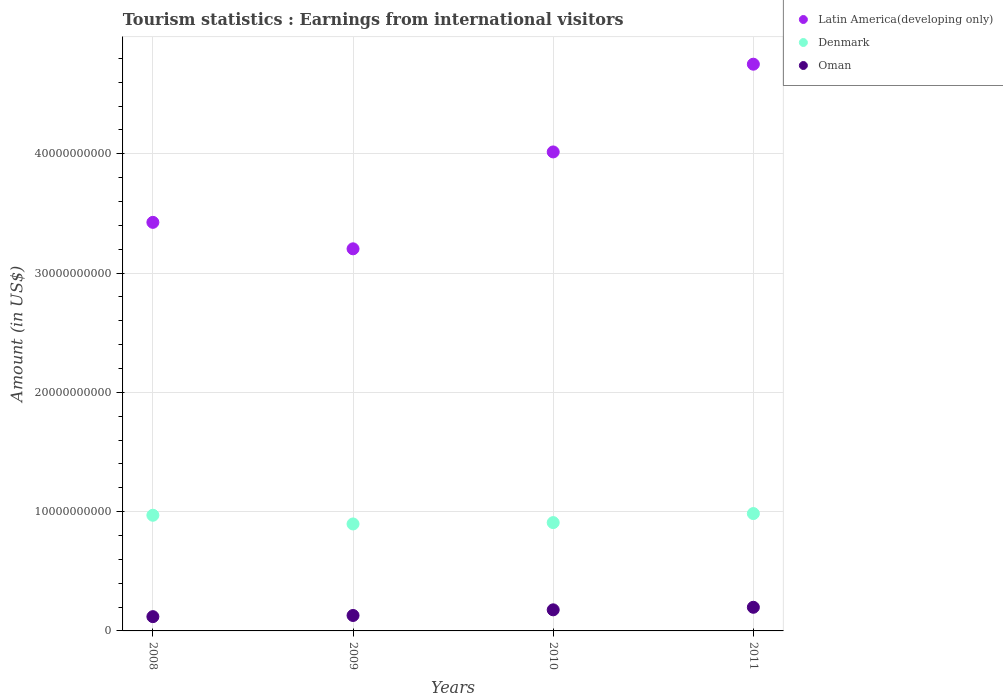What is the earnings from international visitors in Oman in 2010?
Provide a short and direct response. 1.77e+09. Across all years, what is the maximum earnings from international visitors in Latin America(developing only)?
Ensure brevity in your answer.  4.75e+1. Across all years, what is the minimum earnings from international visitors in Oman?
Keep it short and to the point. 1.20e+09. In which year was the earnings from international visitors in Latin America(developing only) maximum?
Make the answer very short. 2011. What is the total earnings from international visitors in Latin America(developing only) in the graph?
Offer a terse response. 1.54e+11. What is the difference between the earnings from international visitors in Oman in 2009 and that in 2010?
Give a very brief answer. -4.73e+08. What is the difference between the earnings from international visitors in Denmark in 2011 and the earnings from international visitors in Latin America(developing only) in 2009?
Give a very brief answer. -2.22e+1. What is the average earnings from international visitors in Latin America(developing only) per year?
Ensure brevity in your answer.  3.85e+1. In the year 2010, what is the difference between the earnings from international visitors in Latin America(developing only) and earnings from international visitors in Oman?
Provide a short and direct response. 3.84e+1. In how many years, is the earnings from international visitors in Oman greater than 30000000000 US$?
Your answer should be compact. 0. What is the ratio of the earnings from international visitors in Denmark in 2009 to that in 2011?
Offer a very short reply. 0.91. Is the earnings from international visitors in Denmark in 2008 less than that in 2011?
Keep it short and to the point. Yes. What is the difference between the highest and the second highest earnings from international visitors in Oman?
Make the answer very short. 2.14e+08. What is the difference between the highest and the lowest earnings from international visitors in Oman?
Give a very brief answer. 7.85e+08. In how many years, is the earnings from international visitors in Denmark greater than the average earnings from international visitors in Denmark taken over all years?
Ensure brevity in your answer.  2. Is it the case that in every year, the sum of the earnings from international visitors in Oman and earnings from international visitors in Denmark  is greater than the earnings from international visitors in Latin America(developing only)?
Keep it short and to the point. No. Does the earnings from international visitors in Latin America(developing only) monotonically increase over the years?
Offer a terse response. No. How many dotlines are there?
Provide a short and direct response. 3. Does the graph contain any zero values?
Offer a terse response. No. Does the graph contain grids?
Your answer should be compact. Yes. How many legend labels are there?
Give a very brief answer. 3. How are the legend labels stacked?
Offer a very short reply. Vertical. What is the title of the graph?
Provide a succinct answer. Tourism statistics : Earnings from international visitors. Does "Europe(developing only)" appear as one of the legend labels in the graph?
Ensure brevity in your answer.  No. What is the label or title of the X-axis?
Give a very brief answer. Years. What is the Amount (in US$) of Latin America(developing only) in 2008?
Offer a terse response. 3.43e+1. What is the Amount (in US$) in Denmark in 2008?
Offer a terse response. 9.70e+09. What is the Amount (in US$) in Oman in 2008?
Offer a very short reply. 1.20e+09. What is the Amount (in US$) of Latin America(developing only) in 2009?
Ensure brevity in your answer.  3.20e+1. What is the Amount (in US$) in Denmark in 2009?
Your answer should be very brief. 8.97e+09. What is the Amount (in US$) of Oman in 2009?
Make the answer very short. 1.30e+09. What is the Amount (in US$) in Latin America(developing only) in 2010?
Ensure brevity in your answer.  4.02e+1. What is the Amount (in US$) in Denmark in 2010?
Offer a terse response. 9.08e+09. What is the Amount (in US$) in Oman in 2010?
Make the answer very short. 1.77e+09. What is the Amount (in US$) in Latin America(developing only) in 2011?
Provide a succinct answer. 4.75e+1. What is the Amount (in US$) in Denmark in 2011?
Your response must be concise. 9.84e+09. What is the Amount (in US$) in Oman in 2011?
Ensure brevity in your answer.  1.98e+09. Across all years, what is the maximum Amount (in US$) in Latin America(developing only)?
Give a very brief answer. 4.75e+1. Across all years, what is the maximum Amount (in US$) in Denmark?
Offer a very short reply. 9.84e+09. Across all years, what is the maximum Amount (in US$) of Oman?
Make the answer very short. 1.98e+09. Across all years, what is the minimum Amount (in US$) of Latin America(developing only)?
Provide a succinct answer. 3.20e+1. Across all years, what is the minimum Amount (in US$) in Denmark?
Offer a very short reply. 8.97e+09. Across all years, what is the minimum Amount (in US$) of Oman?
Offer a terse response. 1.20e+09. What is the total Amount (in US$) in Latin America(developing only) in the graph?
Your answer should be very brief. 1.54e+11. What is the total Amount (in US$) in Denmark in the graph?
Make the answer very short. 3.76e+1. What is the total Amount (in US$) of Oman in the graph?
Provide a short and direct response. 6.24e+09. What is the difference between the Amount (in US$) of Latin America(developing only) in 2008 and that in 2009?
Keep it short and to the point. 2.22e+09. What is the difference between the Amount (in US$) in Denmark in 2008 and that in 2009?
Your answer should be very brief. 7.30e+08. What is the difference between the Amount (in US$) of Oman in 2008 and that in 2009?
Give a very brief answer. -9.80e+07. What is the difference between the Amount (in US$) of Latin America(developing only) in 2008 and that in 2010?
Offer a very short reply. -5.90e+09. What is the difference between the Amount (in US$) of Denmark in 2008 and that in 2010?
Make the answer very short. 6.16e+08. What is the difference between the Amount (in US$) in Oman in 2008 and that in 2010?
Your response must be concise. -5.71e+08. What is the difference between the Amount (in US$) in Latin America(developing only) in 2008 and that in 2011?
Your answer should be compact. -1.33e+1. What is the difference between the Amount (in US$) of Denmark in 2008 and that in 2011?
Give a very brief answer. -1.42e+08. What is the difference between the Amount (in US$) of Oman in 2008 and that in 2011?
Keep it short and to the point. -7.85e+08. What is the difference between the Amount (in US$) in Latin America(developing only) in 2009 and that in 2010?
Your answer should be compact. -8.12e+09. What is the difference between the Amount (in US$) in Denmark in 2009 and that in 2010?
Make the answer very short. -1.14e+08. What is the difference between the Amount (in US$) of Oman in 2009 and that in 2010?
Your response must be concise. -4.73e+08. What is the difference between the Amount (in US$) of Latin America(developing only) in 2009 and that in 2011?
Provide a short and direct response. -1.55e+1. What is the difference between the Amount (in US$) in Denmark in 2009 and that in 2011?
Your answer should be very brief. -8.72e+08. What is the difference between the Amount (in US$) of Oman in 2009 and that in 2011?
Offer a very short reply. -6.87e+08. What is the difference between the Amount (in US$) of Latin America(developing only) in 2010 and that in 2011?
Keep it short and to the point. -7.36e+09. What is the difference between the Amount (in US$) in Denmark in 2010 and that in 2011?
Offer a very short reply. -7.58e+08. What is the difference between the Amount (in US$) in Oman in 2010 and that in 2011?
Keep it short and to the point. -2.14e+08. What is the difference between the Amount (in US$) of Latin America(developing only) in 2008 and the Amount (in US$) of Denmark in 2009?
Your answer should be compact. 2.53e+1. What is the difference between the Amount (in US$) in Latin America(developing only) in 2008 and the Amount (in US$) in Oman in 2009?
Ensure brevity in your answer.  3.30e+1. What is the difference between the Amount (in US$) of Denmark in 2008 and the Amount (in US$) of Oman in 2009?
Your answer should be compact. 8.40e+09. What is the difference between the Amount (in US$) in Latin America(developing only) in 2008 and the Amount (in US$) in Denmark in 2010?
Offer a very short reply. 2.52e+1. What is the difference between the Amount (in US$) of Latin America(developing only) in 2008 and the Amount (in US$) of Oman in 2010?
Offer a terse response. 3.25e+1. What is the difference between the Amount (in US$) of Denmark in 2008 and the Amount (in US$) of Oman in 2010?
Give a very brief answer. 7.93e+09. What is the difference between the Amount (in US$) in Latin America(developing only) in 2008 and the Amount (in US$) in Denmark in 2011?
Provide a short and direct response. 2.44e+1. What is the difference between the Amount (in US$) in Latin America(developing only) in 2008 and the Amount (in US$) in Oman in 2011?
Offer a very short reply. 3.23e+1. What is the difference between the Amount (in US$) in Denmark in 2008 and the Amount (in US$) in Oman in 2011?
Your response must be concise. 7.72e+09. What is the difference between the Amount (in US$) of Latin America(developing only) in 2009 and the Amount (in US$) of Denmark in 2010?
Keep it short and to the point. 2.30e+1. What is the difference between the Amount (in US$) in Latin America(developing only) in 2009 and the Amount (in US$) in Oman in 2010?
Your answer should be very brief. 3.03e+1. What is the difference between the Amount (in US$) of Denmark in 2009 and the Amount (in US$) of Oman in 2010?
Offer a terse response. 7.20e+09. What is the difference between the Amount (in US$) of Latin America(developing only) in 2009 and the Amount (in US$) of Denmark in 2011?
Offer a terse response. 2.22e+1. What is the difference between the Amount (in US$) of Latin America(developing only) in 2009 and the Amount (in US$) of Oman in 2011?
Your answer should be compact. 3.01e+1. What is the difference between the Amount (in US$) of Denmark in 2009 and the Amount (in US$) of Oman in 2011?
Your answer should be very brief. 6.99e+09. What is the difference between the Amount (in US$) of Latin America(developing only) in 2010 and the Amount (in US$) of Denmark in 2011?
Give a very brief answer. 3.03e+1. What is the difference between the Amount (in US$) in Latin America(developing only) in 2010 and the Amount (in US$) in Oman in 2011?
Your response must be concise. 3.82e+1. What is the difference between the Amount (in US$) in Denmark in 2010 and the Amount (in US$) in Oman in 2011?
Provide a short and direct response. 7.10e+09. What is the average Amount (in US$) of Latin America(developing only) per year?
Provide a succinct answer. 3.85e+1. What is the average Amount (in US$) of Denmark per year?
Give a very brief answer. 9.40e+09. What is the average Amount (in US$) of Oman per year?
Ensure brevity in your answer.  1.56e+09. In the year 2008, what is the difference between the Amount (in US$) of Latin America(developing only) and Amount (in US$) of Denmark?
Make the answer very short. 2.46e+1. In the year 2008, what is the difference between the Amount (in US$) of Latin America(developing only) and Amount (in US$) of Oman?
Make the answer very short. 3.31e+1. In the year 2008, what is the difference between the Amount (in US$) in Denmark and Amount (in US$) in Oman?
Your answer should be compact. 8.50e+09. In the year 2009, what is the difference between the Amount (in US$) in Latin America(developing only) and Amount (in US$) in Denmark?
Offer a very short reply. 2.31e+1. In the year 2009, what is the difference between the Amount (in US$) of Latin America(developing only) and Amount (in US$) of Oman?
Offer a very short reply. 3.07e+1. In the year 2009, what is the difference between the Amount (in US$) of Denmark and Amount (in US$) of Oman?
Your answer should be compact. 7.67e+09. In the year 2010, what is the difference between the Amount (in US$) of Latin America(developing only) and Amount (in US$) of Denmark?
Your response must be concise. 3.11e+1. In the year 2010, what is the difference between the Amount (in US$) in Latin America(developing only) and Amount (in US$) in Oman?
Give a very brief answer. 3.84e+1. In the year 2010, what is the difference between the Amount (in US$) of Denmark and Amount (in US$) of Oman?
Ensure brevity in your answer.  7.31e+09. In the year 2011, what is the difference between the Amount (in US$) of Latin America(developing only) and Amount (in US$) of Denmark?
Give a very brief answer. 3.77e+1. In the year 2011, what is the difference between the Amount (in US$) of Latin America(developing only) and Amount (in US$) of Oman?
Your answer should be compact. 4.55e+1. In the year 2011, what is the difference between the Amount (in US$) in Denmark and Amount (in US$) in Oman?
Offer a terse response. 7.86e+09. What is the ratio of the Amount (in US$) in Latin America(developing only) in 2008 to that in 2009?
Provide a succinct answer. 1.07. What is the ratio of the Amount (in US$) of Denmark in 2008 to that in 2009?
Keep it short and to the point. 1.08. What is the ratio of the Amount (in US$) of Oman in 2008 to that in 2009?
Provide a short and direct response. 0.92. What is the ratio of the Amount (in US$) of Latin America(developing only) in 2008 to that in 2010?
Keep it short and to the point. 0.85. What is the ratio of the Amount (in US$) of Denmark in 2008 to that in 2010?
Ensure brevity in your answer.  1.07. What is the ratio of the Amount (in US$) in Oman in 2008 to that in 2010?
Provide a succinct answer. 0.68. What is the ratio of the Amount (in US$) of Latin America(developing only) in 2008 to that in 2011?
Provide a succinct answer. 0.72. What is the ratio of the Amount (in US$) of Denmark in 2008 to that in 2011?
Provide a short and direct response. 0.99. What is the ratio of the Amount (in US$) in Oman in 2008 to that in 2011?
Provide a short and direct response. 0.6. What is the ratio of the Amount (in US$) of Latin America(developing only) in 2009 to that in 2010?
Offer a very short reply. 0.8. What is the ratio of the Amount (in US$) in Denmark in 2009 to that in 2010?
Make the answer very short. 0.99. What is the ratio of the Amount (in US$) in Oman in 2009 to that in 2010?
Keep it short and to the point. 0.73. What is the ratio of the Amount (in US$) in Latin America(developing only) in 2009 to that in 2011?
Provide a short and direct response. 0.67. What is the ratio of the Amount (in US$) of Denmark in 2009 to that in 2011?
Offer a very short reply. 0.91. What is the ratio of the Amount (in US$) in Oman in 2009 to that in 2011?
Provide a short and direct response. 0.65. What is the ratio of the Amount (in US$) in Latin America(developing only) in 2010 to that in 2011?
Your response must be concise. 0.85. What is the ratio of the Amount (in US$) in Denmark in 2010 to that in 2011?
Your response must be concise. 0.92. What is the ratio of the Amount (in US$) in Oman in 2010 to that in 2011?
Provide a short and direct response. 0.89. What is the difference between the highest and the second highest Amount (in US$) of Latin America(developing only)?
Offer a terse response. 7.36e+09. What is the difference between the highest and the second highest Amount (in US$) of Denmark?
Offer a very short reply. 1.42e+08. What is the difference between the highest and the second highest Amount (in US$) in Oman?
Offer a terse response. 2.14e+08. What is the difference between the highest and the lowest Amount (in US$) of Latin America(developing only)?
Your answer should be compact. 1.55e+1. What is the difference between the highest and the lowest Amount (in US$) of Denmark?
Keep it short and to the point. 8.72e+08. What is the difference between the highest and the lowest Amount (in US$) of Oman?
Make the answer very short. 7.85e+08. 